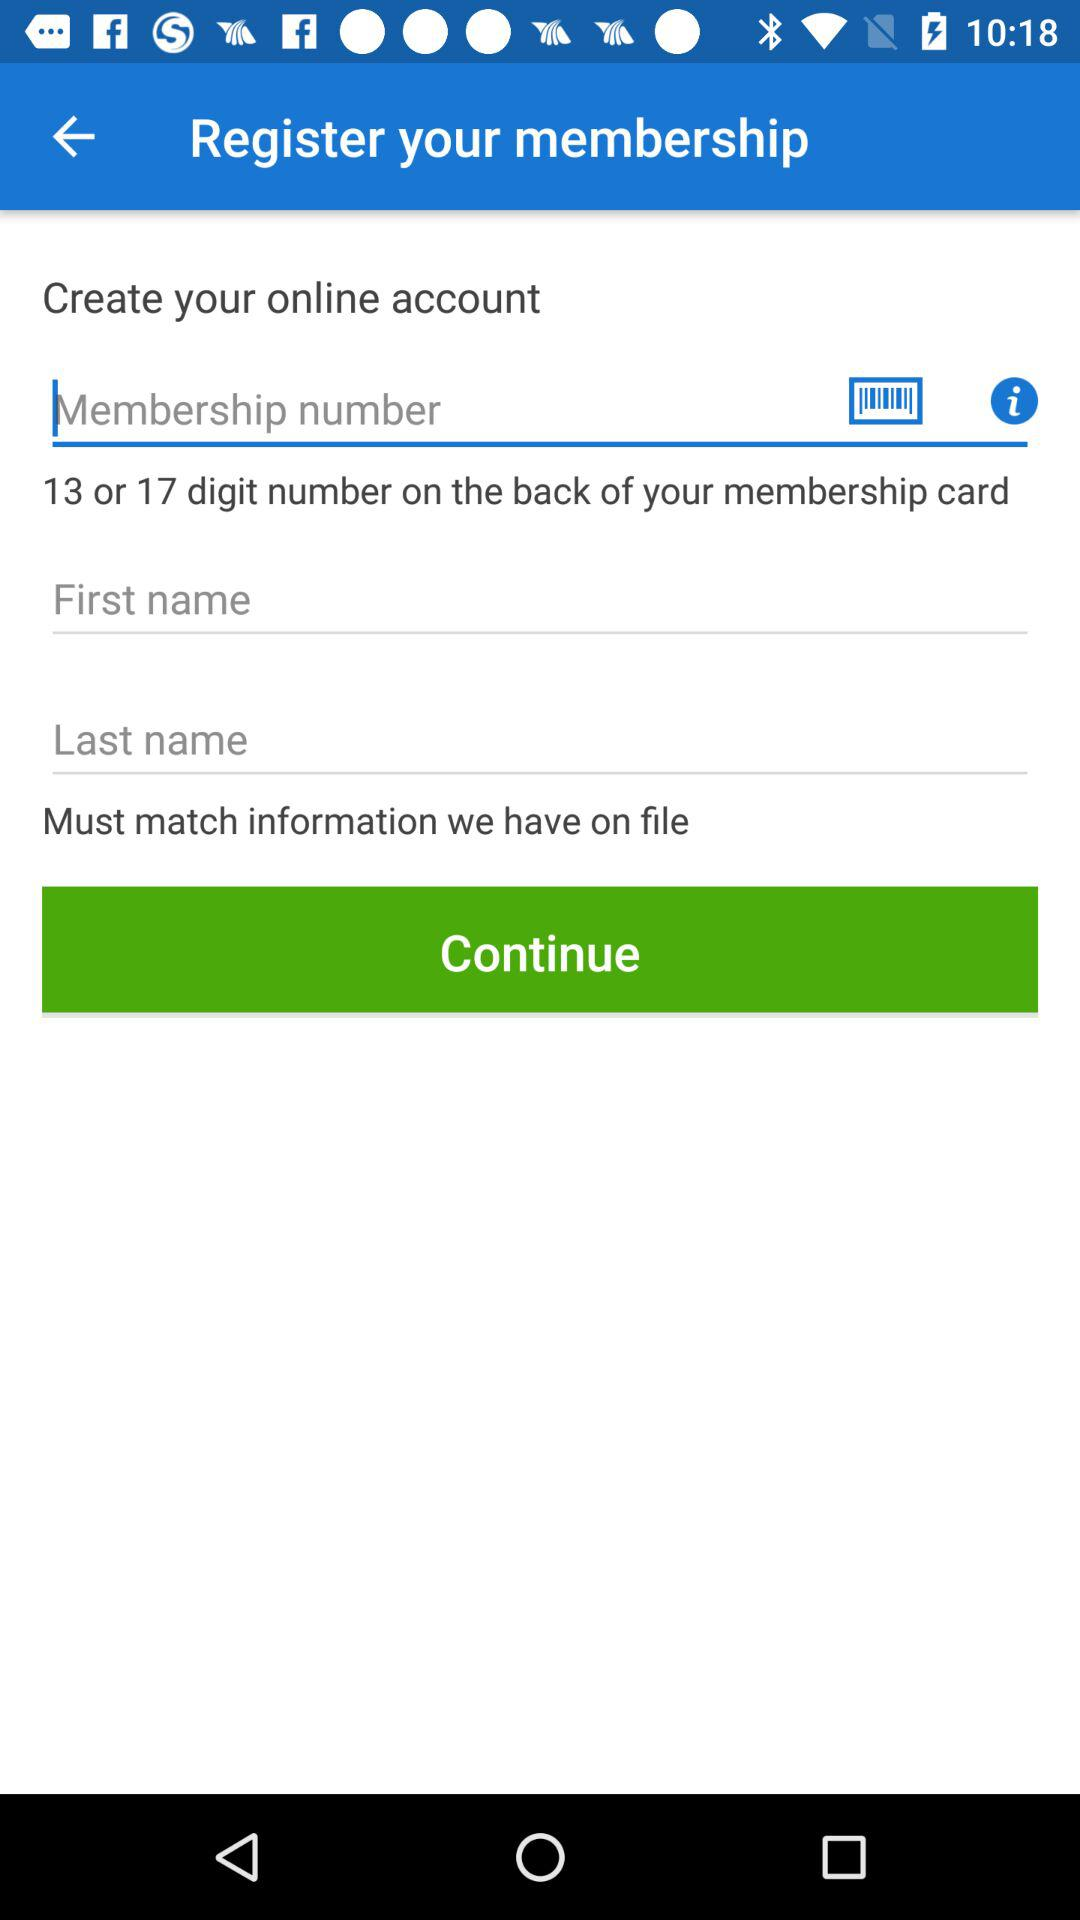How many text inputs are required to create an account?
Answer the question using a single word or phrase. 3 